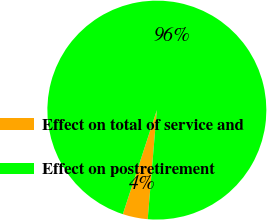Convert chart to OTSL. <chart><loc_0><loc_0><loc_500><loc_500><pie_chart><fcel>Effect on total of service and<fcel>Effect on postretirement<nl><fcel>3.7%<fcel>96.3%<nl></chart> 